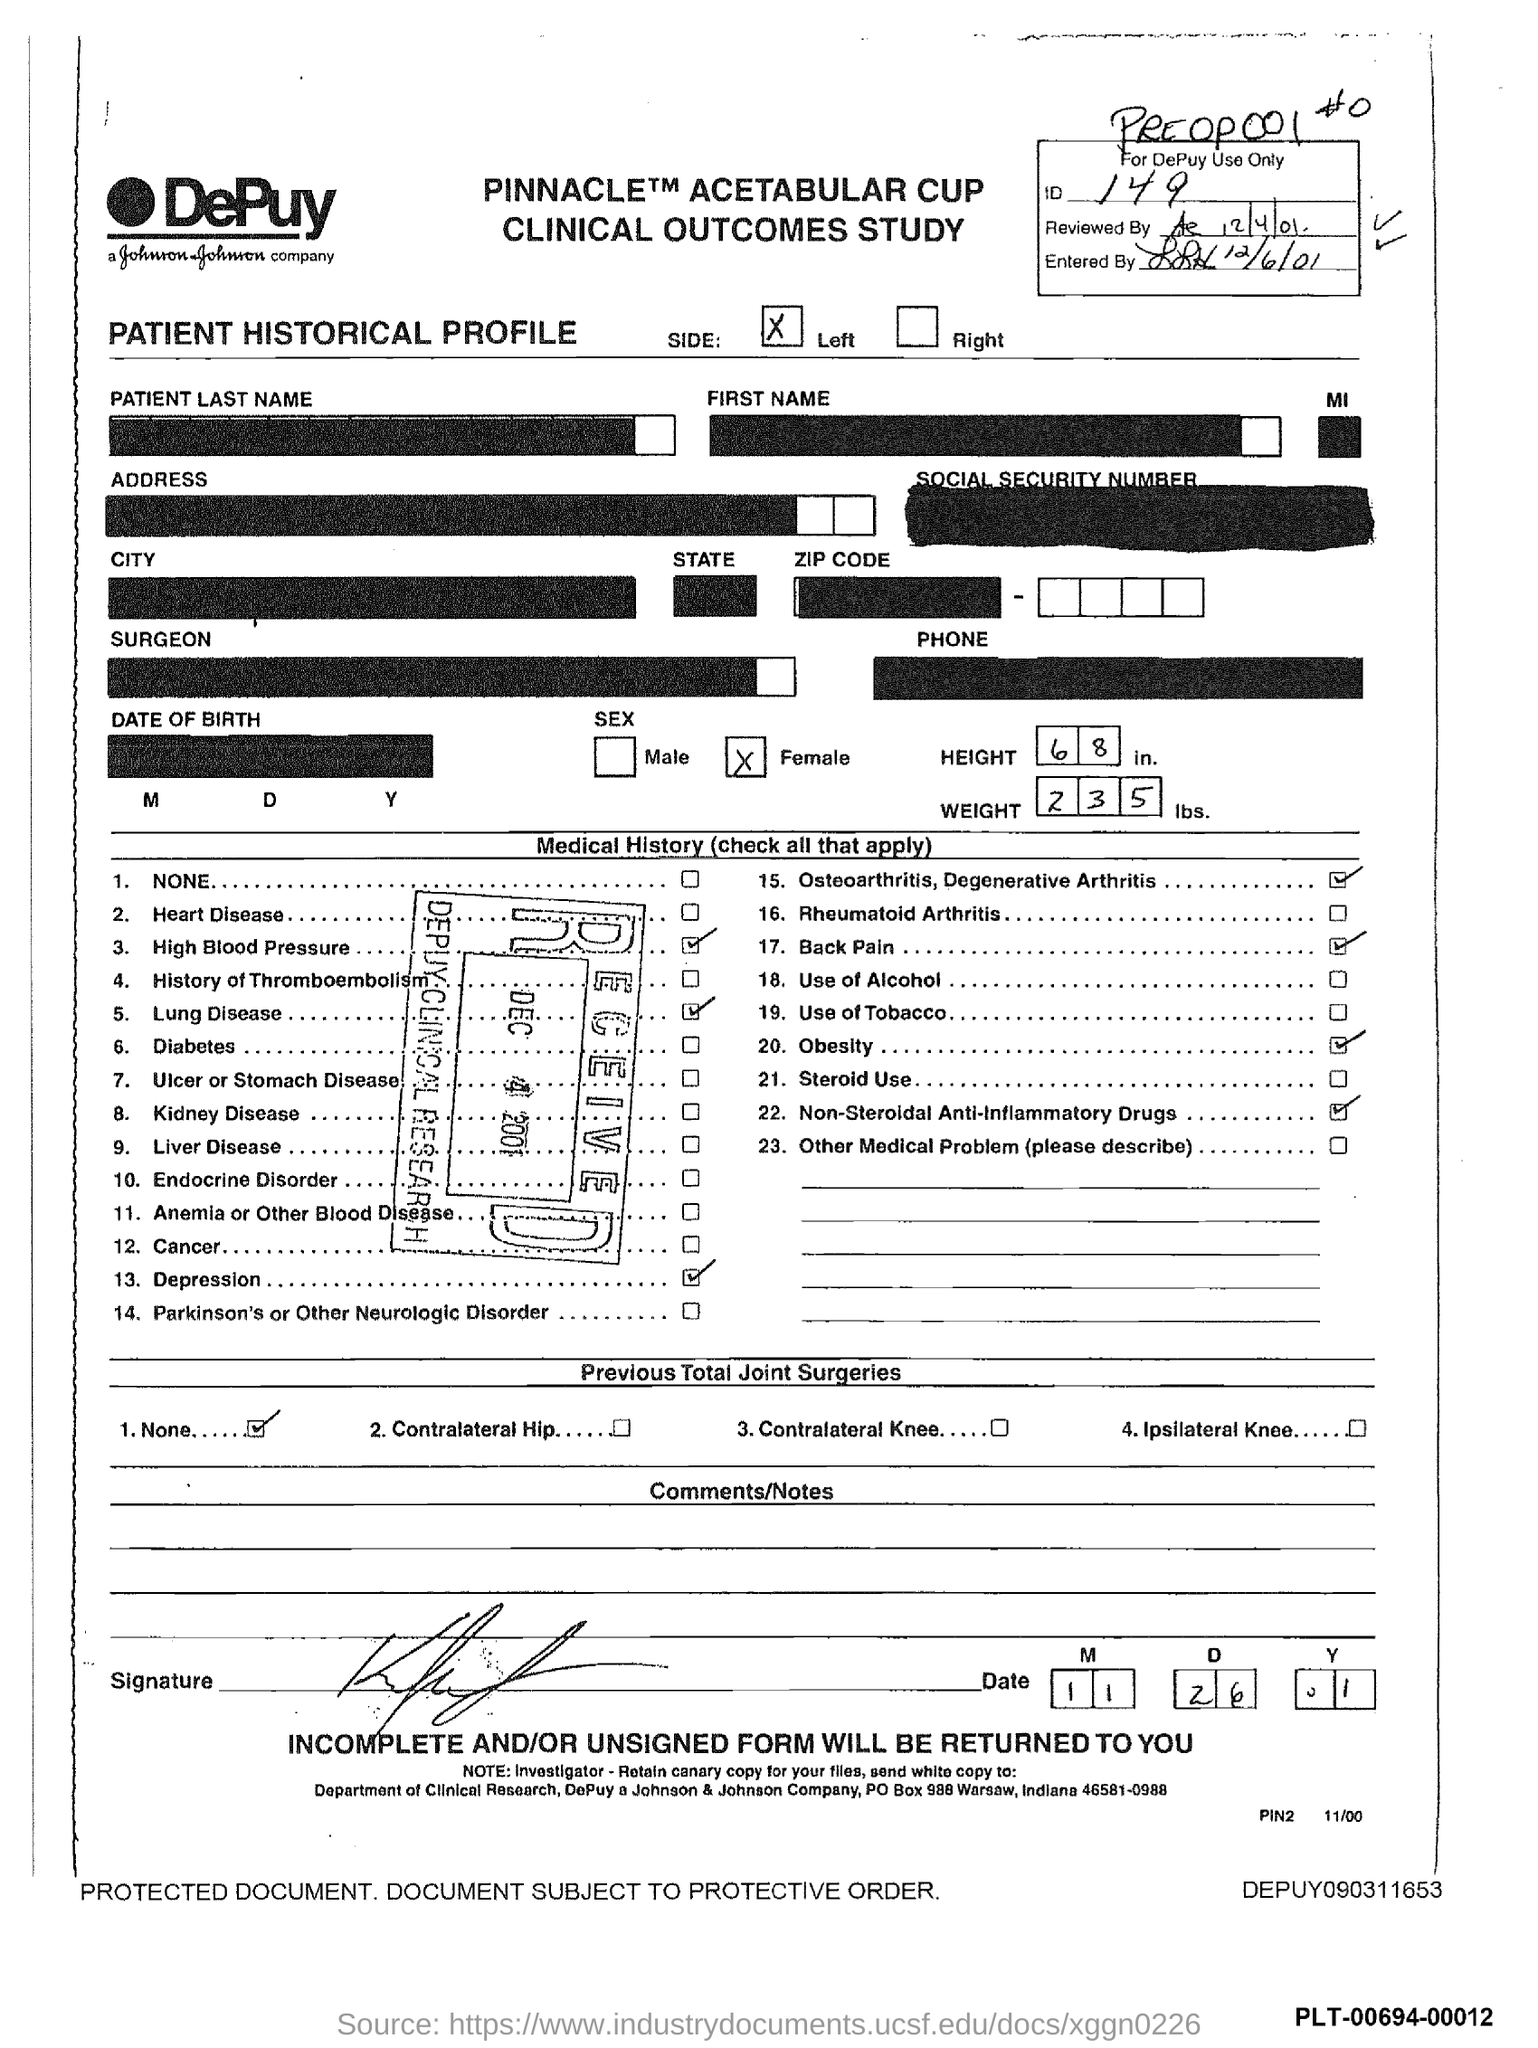Outline some significant characteristics in this image. The weight of the patient is 235. The ID number is 149. The date mentioned on the received stamp is December 4, 2001. The reviewed date is December 4th, 2001. The patient's height is 68 inches. 